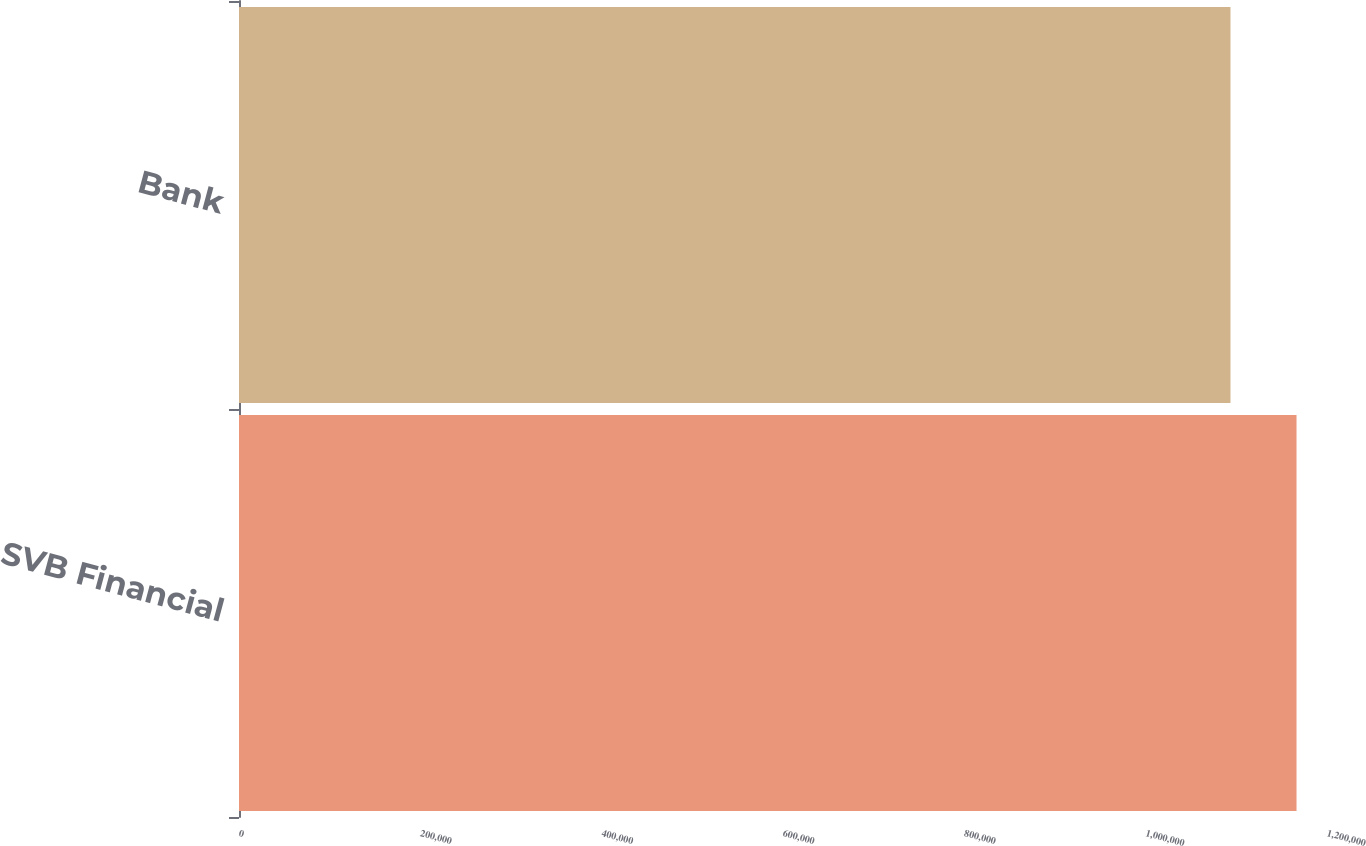Convert chart to OTSL. <chart><loc_0><loc_0><loc_500><loc_500><bar_chart><fcel>SVB Financial<fcel>Bank<nl><fcel>1.16638e+06<fcel>1.09355e+06<nl></chart> 